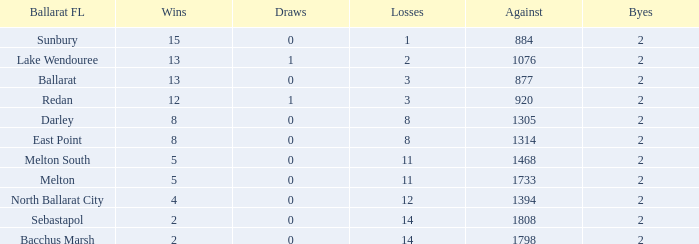What is the number of losses for a ballarat fl team from melton south with an against score greater than 1468? 0.0. 